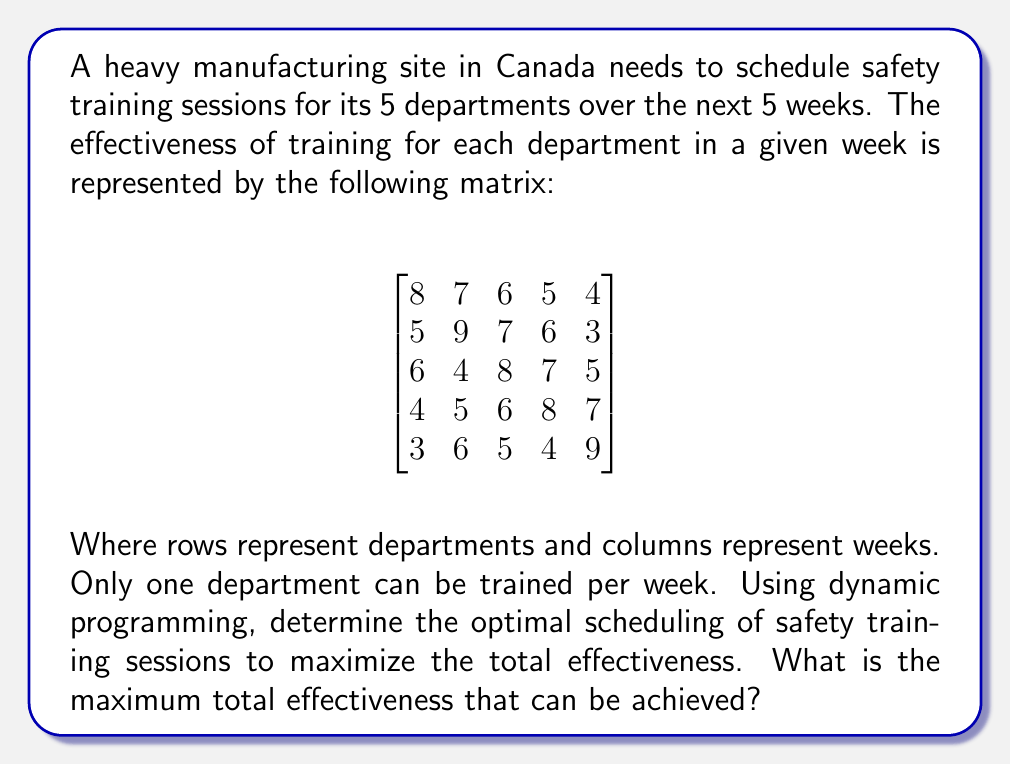Show me your answer to this math problem. To solve this problem using dynamic programming, we'll follow these steps:

1) Define the subproblem:
   Let $dp[i][j]$ be the maximum effectiveness that can be achieved by scheduling the first $i$ departments in the first $j$ weeks.

2) Define the recurrence relation:
   $$dp[i][j] = \max(dp[i-1][j-1] + effectiveness[i][j], dp[i][j-1])$$
   This means we either schedule department $i$ in week $j$, or we don't.

3) Initialize the base cases:
   $dp[0][j] = 0$ for all $j$ (no departments scheduled)
   $dp[i][0] = 0$ for all $i$ (no weeks available)

4) Fill the DP table:

   We'll use a 6x6 table to include the base cases:

   $$
   \begin{bmatrix}
   0 & 0 & 0 & 0 & 0 & 0 \\
   0 & 8 & 8 & 8 & 8 & 8 \\
   0 & 8 & 17 & 17 & 17 & 17 \\
   0 & 8 & 17 & 25 & 25 & 25 \\
   0 & 8 & 17 & 25 & 33 & 33 \\
   0 & 8 & 17 & 25 & 33 & 42
   \end{bmatrix}
   $$

5) The optimal solution is in $dp[5][5] = 42$

6) To reconstruct the optimal schedule, we backtrack through the table:
   - If $dp[i][j] = dp[i-1][j-1] + effectiveness[i][j]$, schedule department $i$ in week $j$
   - Otherwise, move to $dp[i][j-1]$

   This gives us the schedule: Department 5 in Week 5, Department 4 in Week 4, Department 3 in Week 3, Department 2 in Week 2, and Department 1 in Week 1.
Answer: The maximum total effectiveness that can be achieved is 42. The optimal schedule is:
Week 1: Department 1
Week 2: Department 2
Week 3: Department 3
Week 4: Department 4
Week 5: Department 5 